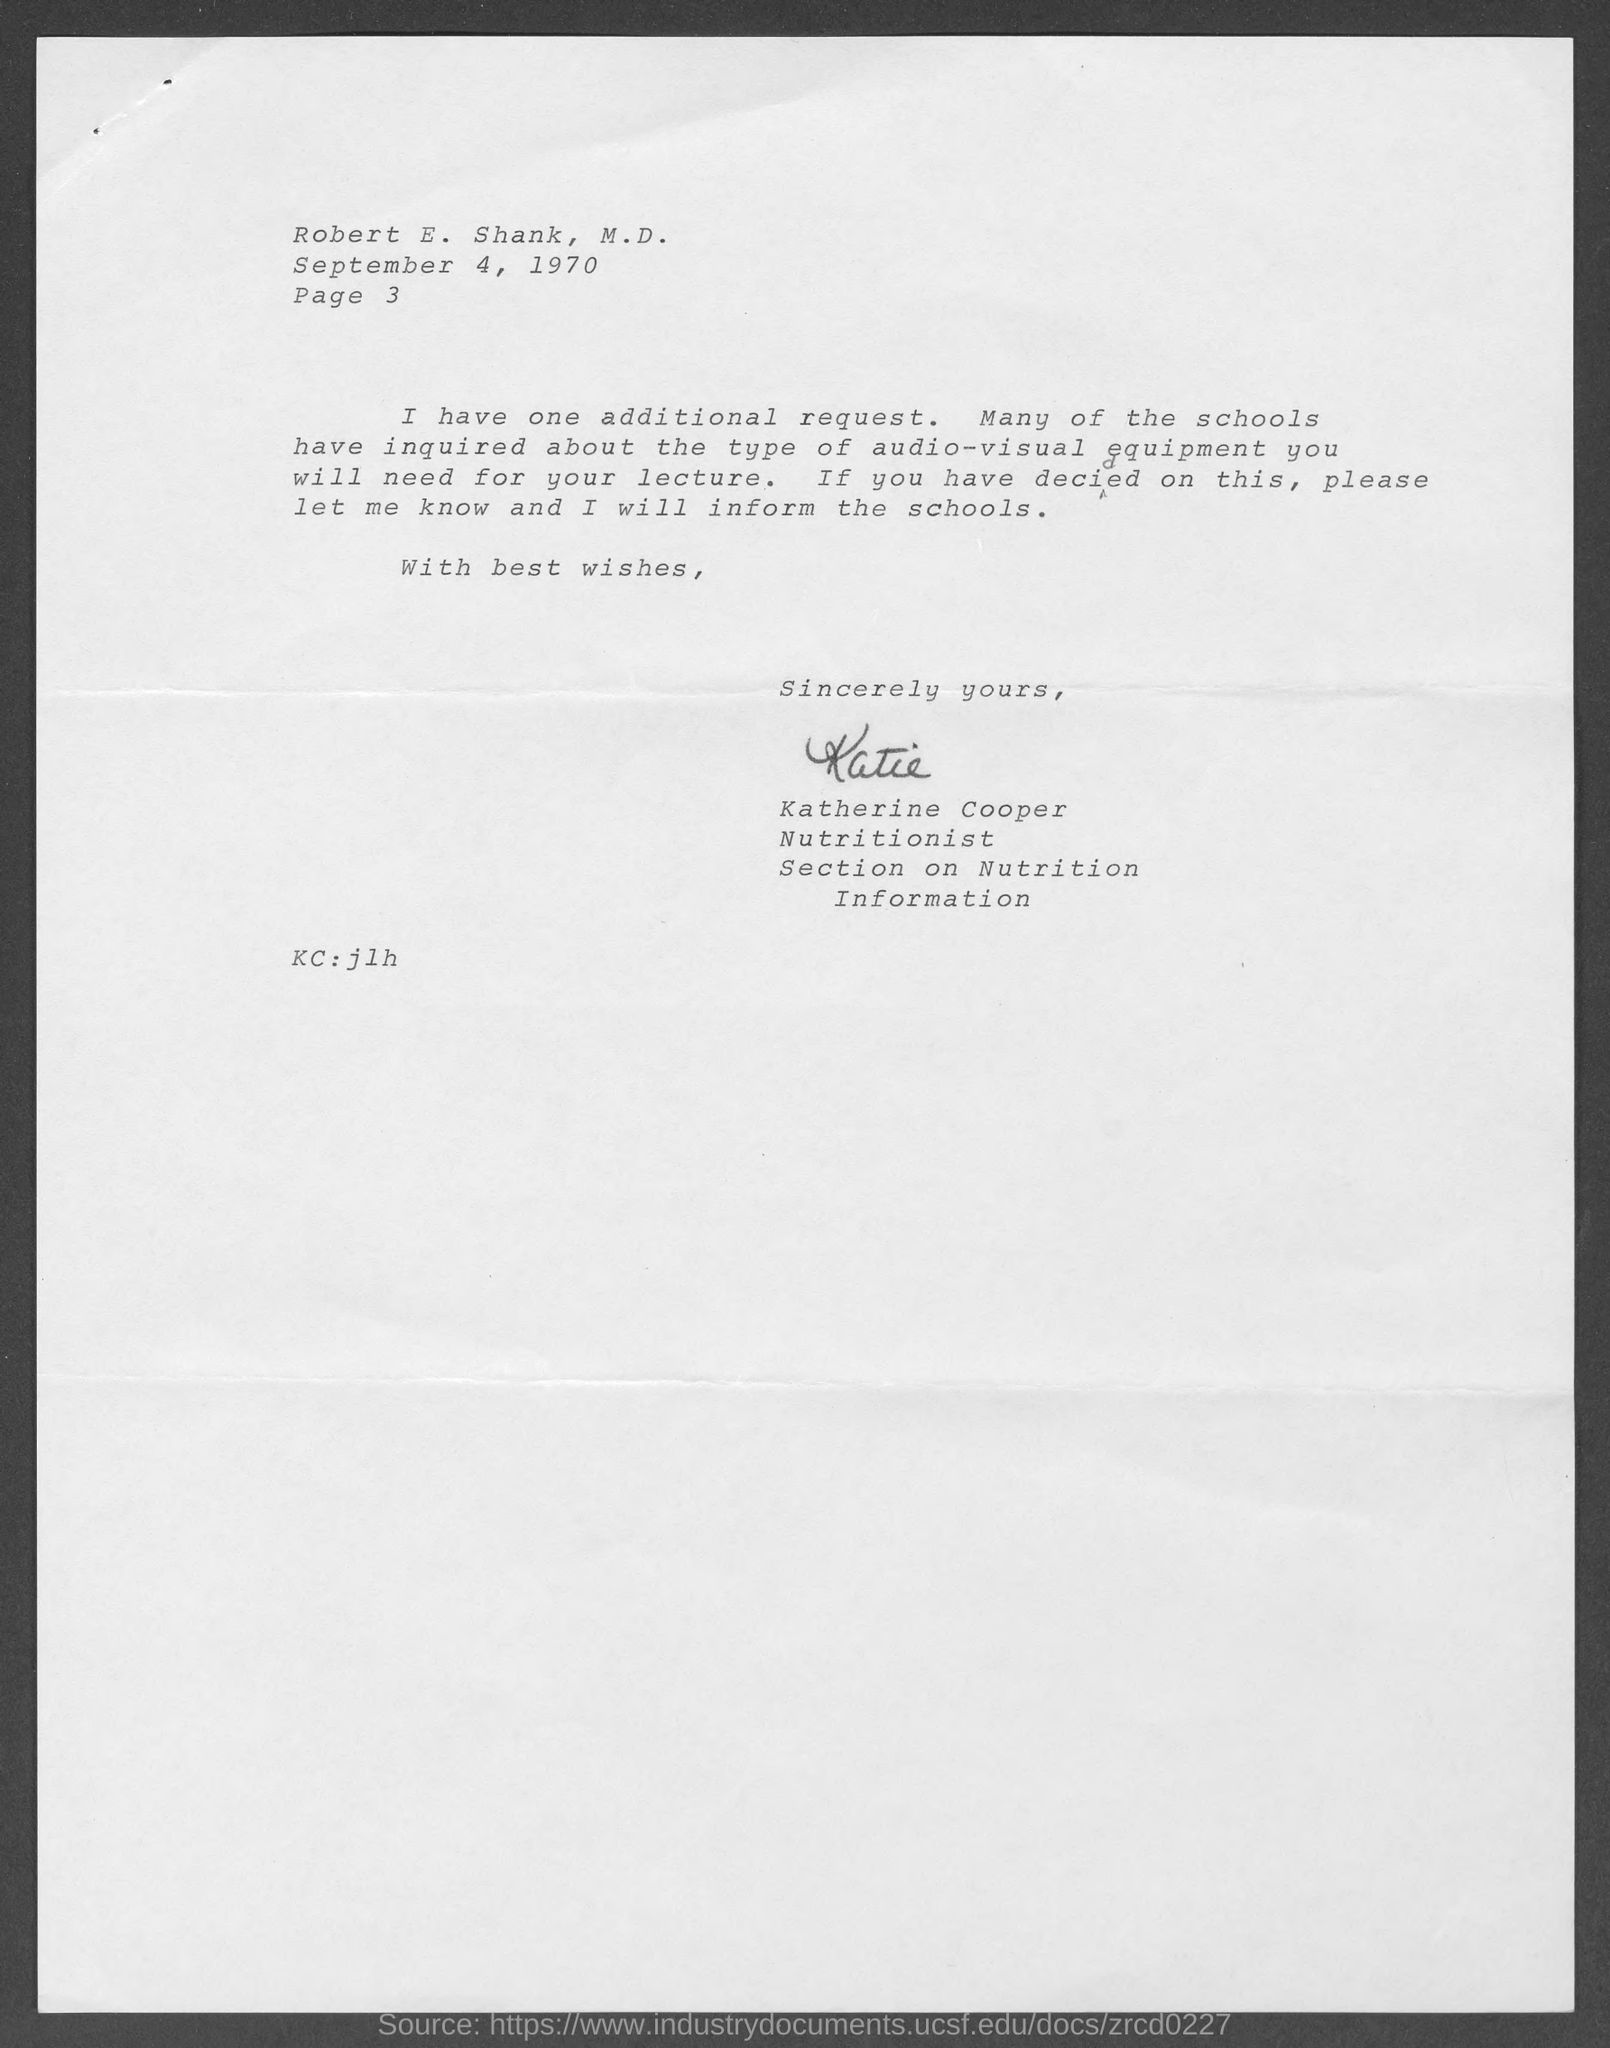When is the memorandum dated on ?
Offer a very short reply. September 4, 1970. What is the Page number written in the document ?
Your answer should be compact. Page 3. What is written in the "KC" Field ?
Provide a short and direct response. Jlh. 